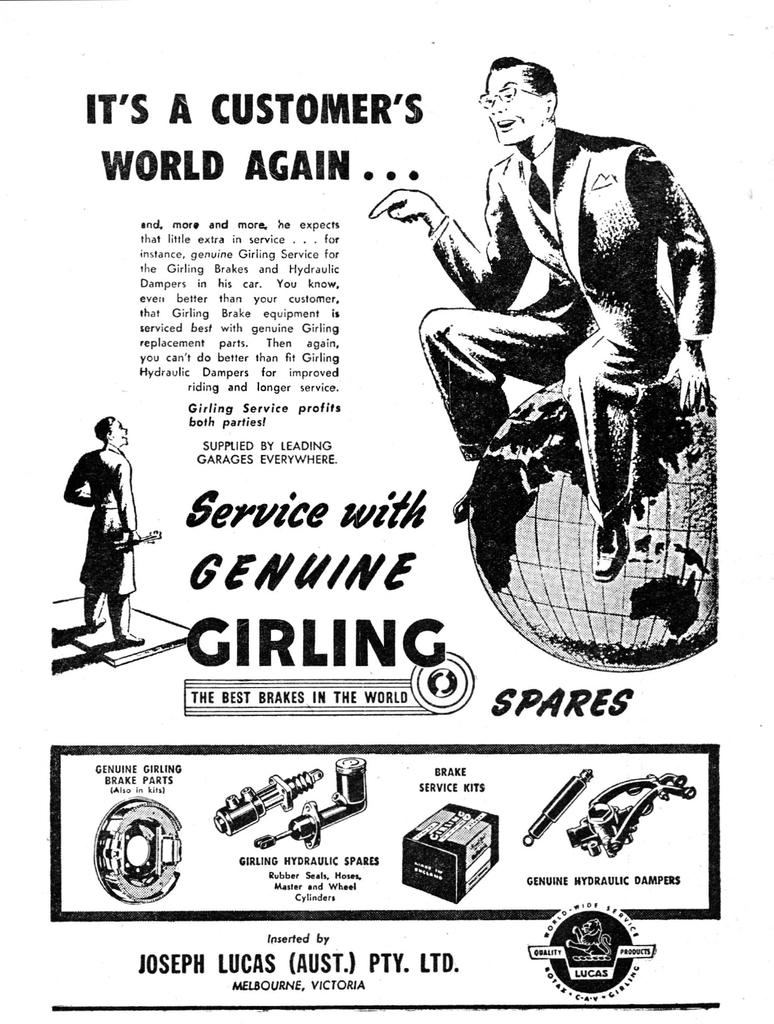What is the main subject of the poster in the image? There is a poster with information in the image, but the specific content of the poster is not mentioned. What else can be seen in the image besides the poster? There is an image of a man in the image. What is the man doing in the image? The man is sitting on a globe structure. Can you see any deer in the image? There is no mention of deer in the image, so we cannot say if any are present. What type of engine is powering the globe structure? There is no mention of an engine in the image, so we cannot determine if one is present or its type. 